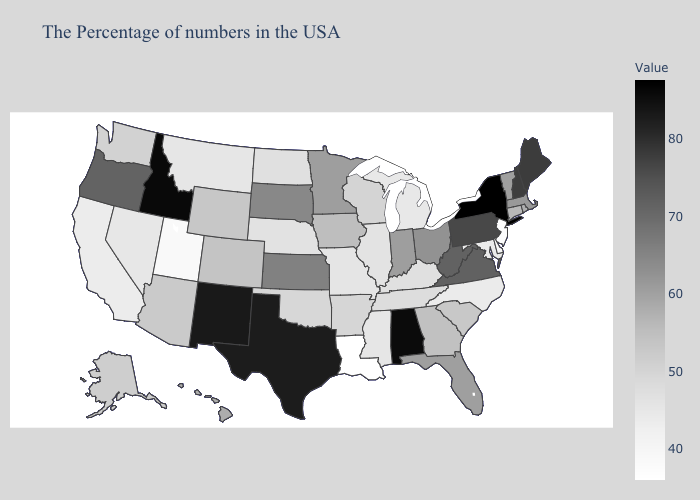Among the states that border Kansas , which have the lowest value?
Be succinct. Missouri. Among the states that border Montana , does South Dakota have the lowest value?
Short answer required. No. Among the states that border Washington , which have the highest value?
Write a very short answer. Idaho. Does the map have missing data?
Quick response, please. No. 